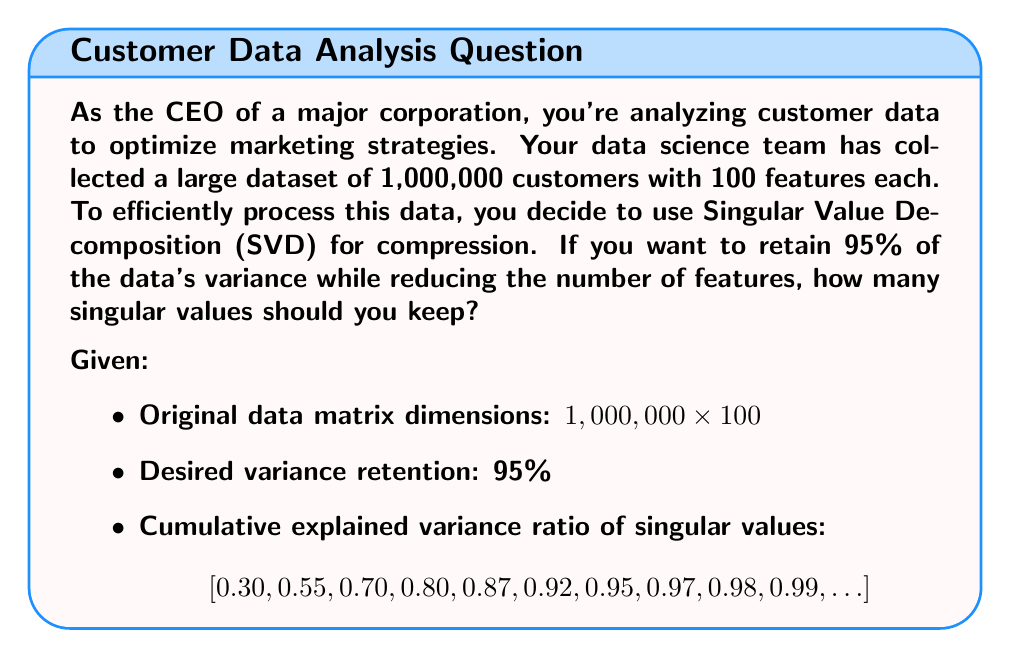Show me your answer to this math problem. To solve this problem, we'll follow these steps:

1) First, recall that Singular Value Decomposition (SVD) decomposes a matrix $A$ into three matrices:

   $A = U\Sigma V^T$

   where $\Sigma$ contains the singular values in descending order.

2) The cumulative explained variance ratio represents the proportion of variance explained by the first k singular values. It's calculated as:

   $$\frac{\sum_{i=1}^k \sigma_i^2}{\sum_{i=1}^n \sigma_i^2}$$

   where $\sigma_i$ are the singular values and n is the total number of singular values.

3) We're given the cumulative explained variance ratio for the first few singular values. We need to find the smallest k where the cumulative explained variance is at least 95%.

4) Looking at the given cumulative explained variance ratio:
   [0.30, 0.55, 0.70, 0.80, 0.87, 0.92, 0.95, 0.97, 0.98, 0.99, ...]

5) We can see that at k = 7, the cumulative explained variance reaches 0.95, which is 95%.

6) Therefore, we need to keep the first 7 singular values to retain 95% of the data's variance.

7) This means we can reduce our feature space from 100 to 7 dimensions while still retaining 95% of the original information.

8) The compressed data will have dimensions 1,000,000 × 7, significantly reducing the computational complexity for further analysis.
Answer: 7 singular values 